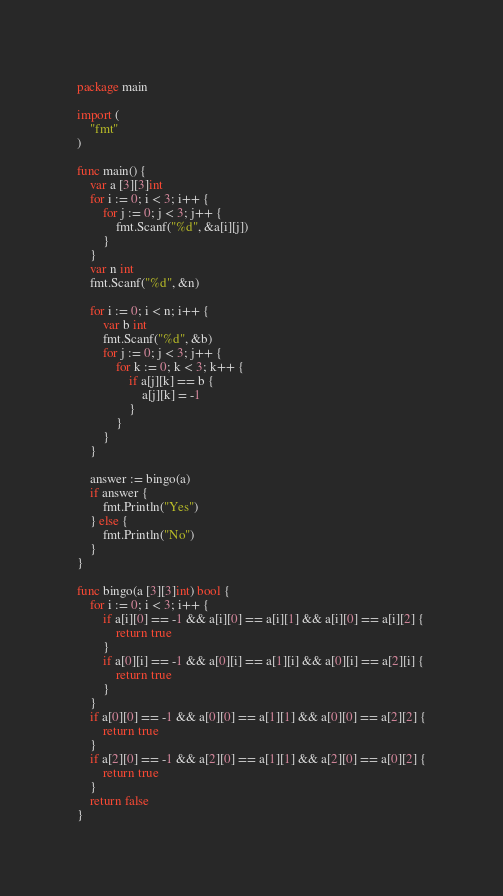Convert code to text. <code><loc_0><loc_0><loc_500><loc_500><_Go_>package main

import (
	"fmt"
)

func main() {
	var a [3][3]int
	for i := 0; i < 3; i++ {
		for j := 0; j < 3; j++ {
			fmt.Scanf("%d", &a[i][j])
		}
	}
	var n int
	fmt.Scanf("%d", &n)

	for i := 0; i < n; i++ {
		var b int
		fmt.Scanf("%d", &b)
		for j := 0; j < 3; j++ {
			for k := 0; k < 3; k++ {
				if a[j][k] == b {
					a[j][k] = -1
				}
			}
		}
	}

	answer := bingo(a)
	if answer {
		fmt.Println("Yes")
	} else {
		fmt.Println("No")
	}
}

func bingo(a [3][3]int) bool {
	for i := 0; i < 3; i++ {
		if a[i][0] == -1 && a[i][0] == a[i][1] && a[i][0] == a[i][2] {
			return true
		}
		if a[0][i] == -1 && a[0][i] == a[1][i] && a[0][i] == a[2][i] {
			return true
		}
	}
	if a[0][0] == -1 && a[0][0] == a[1][1] && a[0][0] == a[2][2] {
		return true
	}
	if a[2][0] == -1 && a[2][0] == a[1][1] && a[2][0] == a[0][2] {
		return true
	}
	return false
}
</code> 